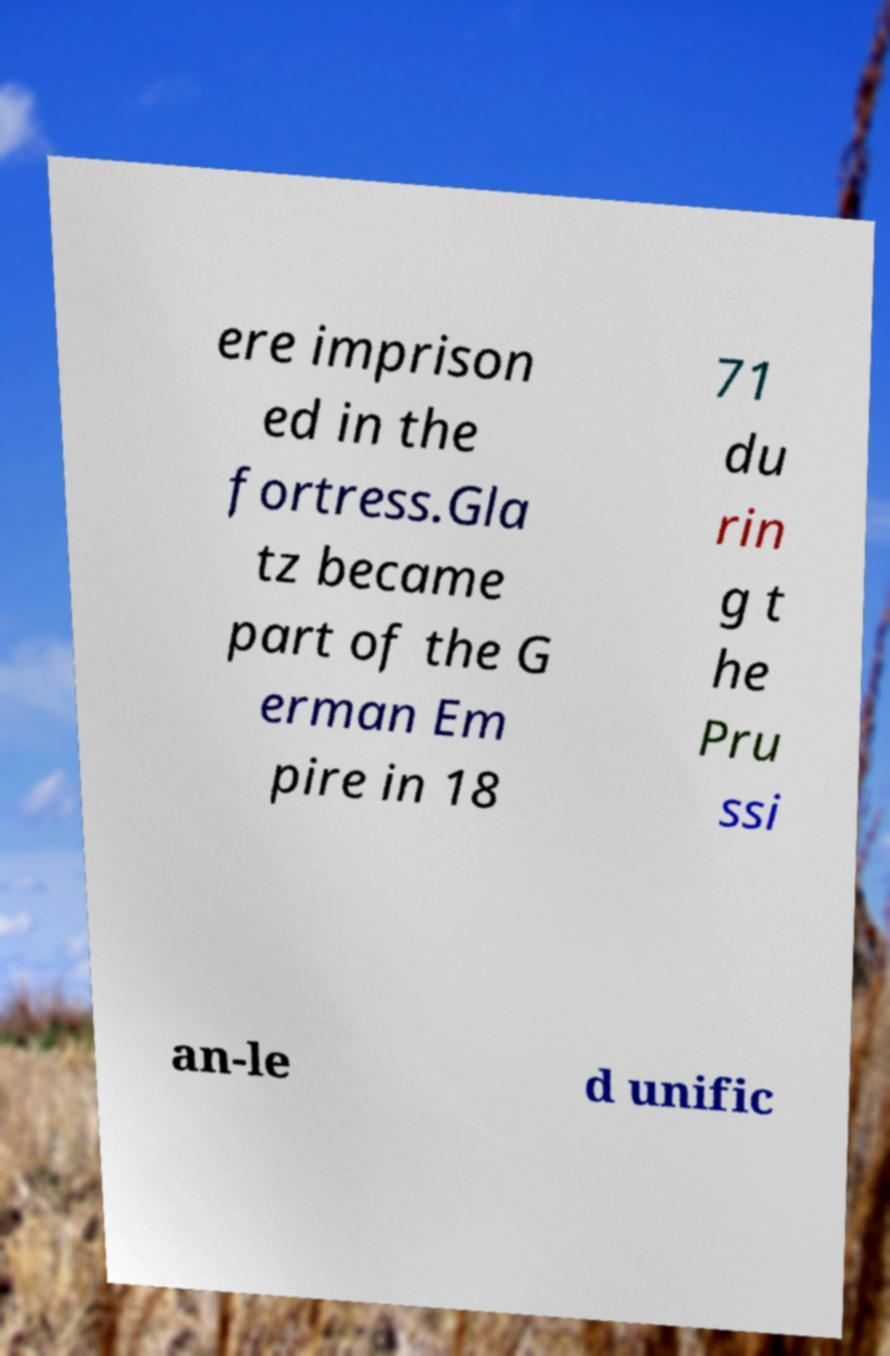Can you read and provide the text displayed in the image?This photo seems to have some interesting text. Can you extract and type it out for me? ere imprison ed in the fortress.Gla tz became part of the G erman Em pire in 18 71 du rin g t he Pru ssi an-le d unific 